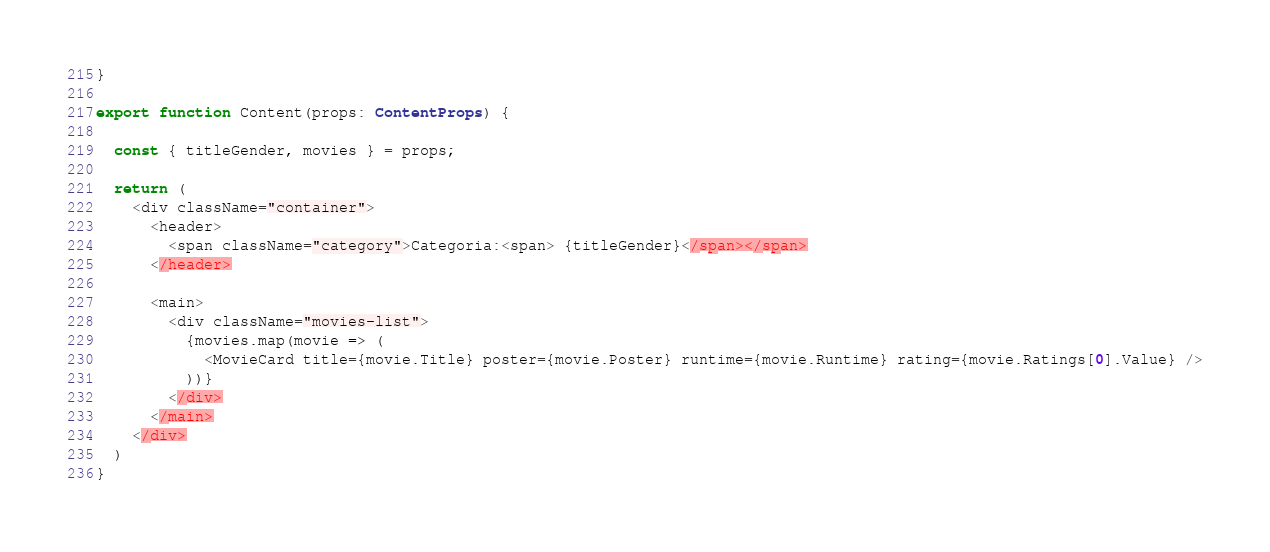<code> <loc_0><loc_0><loc_500><loc_500><_TypeScript_>}

export function Content(props: ContentProps) {

  const { titleGender, movies } = props;

  return (
    <div className="container">
      <header>
        <span className="category">Categoria:<span> {titleGender}</span></span>
      </header>

      <main>
        <div className="movies-list">
          {movies.map(movie => (
            <MovieCard title={movie.Title} poster={movie.Poster} runtime={movie.Runtime} rating={movie.Ratings[0].Value} />
          ))}
        </div>
      </main>
    </div>
  )
}</code> 